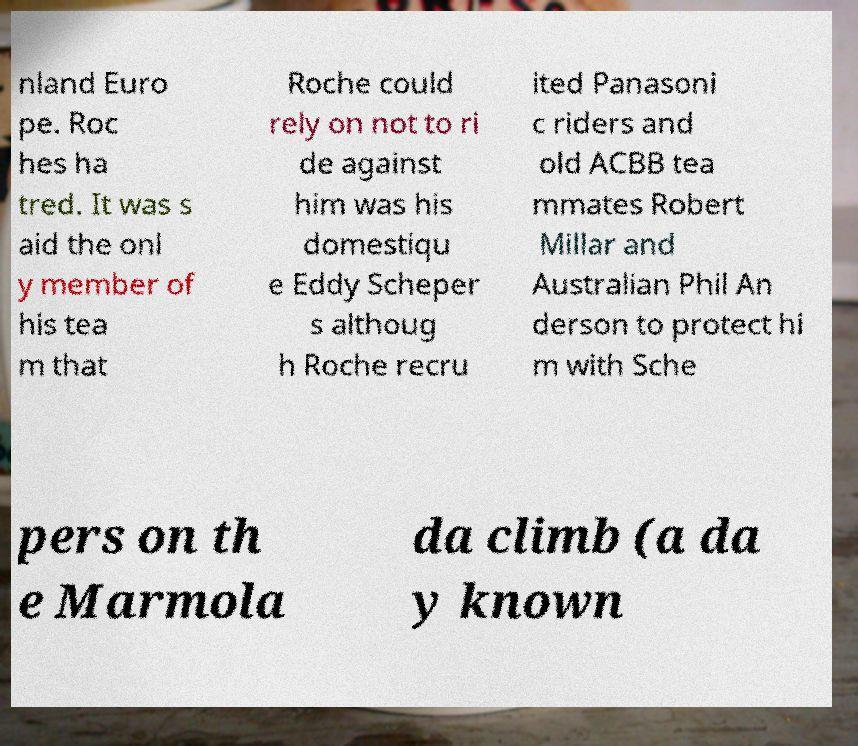Can you accurately transcribe the text from the provided image for me? nland Euro pe. Roc hes ha tred. It was s aid the onl y member of his tea m that Roche could rely on not to ri de against him was his domestiqu e Eddy Scheper s althoug h Roche recru ited Panasoni c riders and old ACBB tea mmates Robert Millar and Australian Phil An derson to protect hi m with Sche pers on th e Marmola da climb (a da y known 